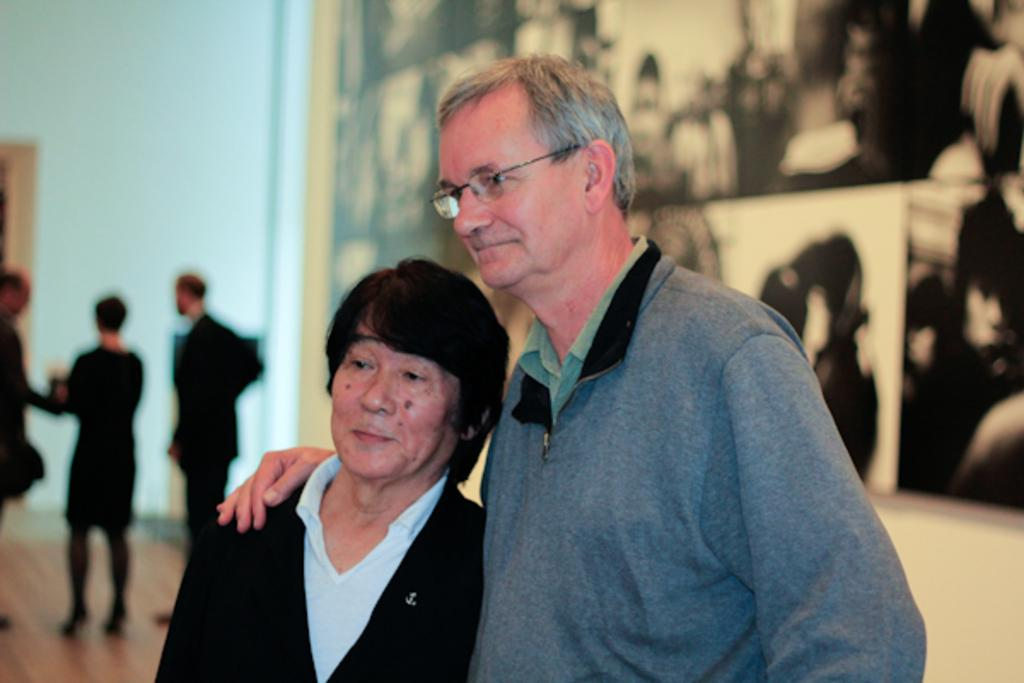What is present in the image? There is a wall and people in the image. Can you describe the clothing of one of the individuals? A man is wearing a grey color jacket. Are there any other jackets visible in the image? Yes, a person is wearing a black color jacket. How many babies are visible in the image? There are no babies present in the image. Is there a bear wearing a jacket in the image? There is no bear present in the image. 